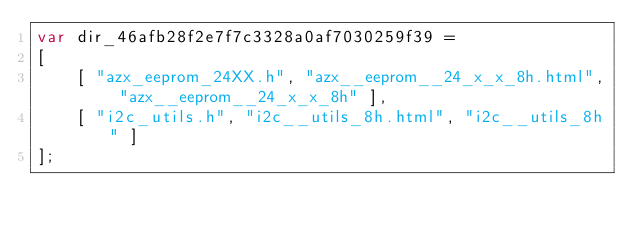<code> <loc_0><loc_0><loc_500><loc_500><_JavaScript_>var dir_46afb28f2e7f7c3328a0af7030259f39 =
[
    [ "azx_eeprom_24XX.h", "azx__eeprom__24_x_x_8h.html", "azx__eeprom__24_x_x_8h" ],
    [ "i2c_utils.h", "i2c__utils_8h.html", "i2c__utils_8h" ]
];</code> 